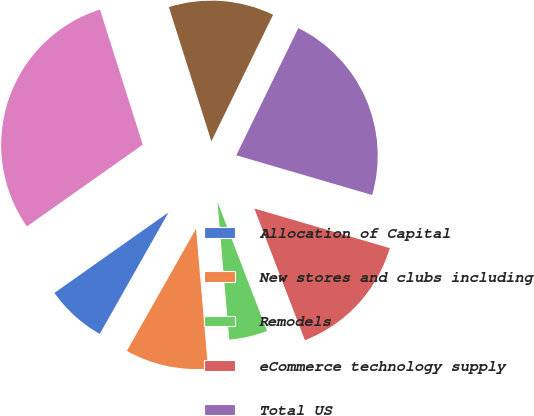Convert chart. <chart><loc_0><loc_0><loc_500><loc_500><pie_chart><fcel>Allocation of Capital<fcel>New stores and clubs including<fcel>Remodels<fcel>eCommerce technology supply<fcel>Total US<fcel>Walmart International<fcel>Total capital expenditures<nl><fcel>7.02%<fcel>9.56%<fcel>4.47%<fcel>14.64%<fcel>22.31%<fcel>12.1%<fcel>29.9%<nl></chart> 